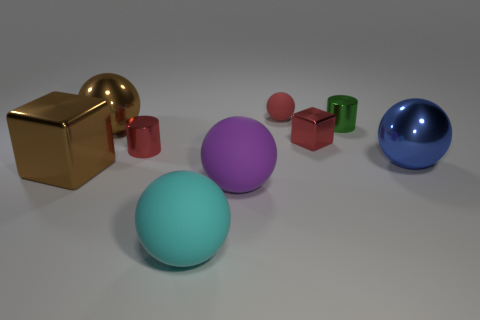Are there more big balls than metal objects?
Give a very brief answer. No. What is the size of the red shiny object that is right of the ball behind the metallic sphere that is left of the blue ball?
Provide a succinct answer. Small. There is a red cylinder; is it the same size as the cube in front of the small red metal cube?
Keep it short and to the point. No. Are there fewer large balls in front of the red cube than small objects?
Provide a short and direct response. Yes. How many tiny metal cylinders have the same color as the small shiny cube?
Provide a short and direct response. 1. Are there fewer green cylinders than large yellow cylinders?
Your response must be concise. No. Is the brown sphere made of the same material as the big cyan sphere?
Ensure brevity in your answer.  No. How many other objects are the same size as the red cylinder?
Provide a short and direct response. 3. The big metallic sphere on the right side of the rubber thing behind the large brown shiny cube is what color?
Offer a very short reply. Blue. What number of other objects are the same shape as the small green metal thing?
Make the answer very short. 1. 